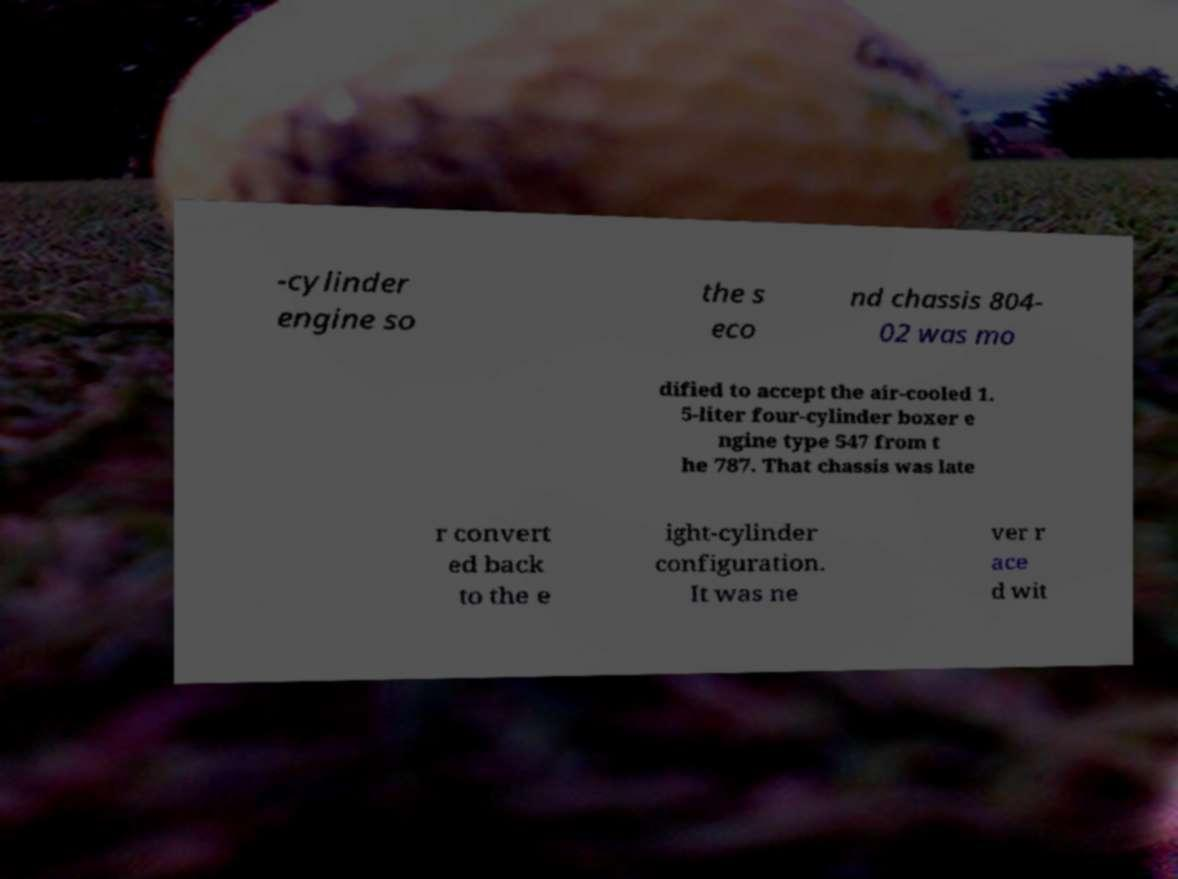What messages or text are displayed in this image? I need them in a readable, typed format. -cylinder engine so the s eco nd chassis 804- 02 was mo dified to accept the air-cooled 1. 5-liter four-cylinder boxer e ngine type 547 from t he 787. That chassis was late r convert ed back to the e ight-cylinder configuration. It was ne ver r ace d wit 